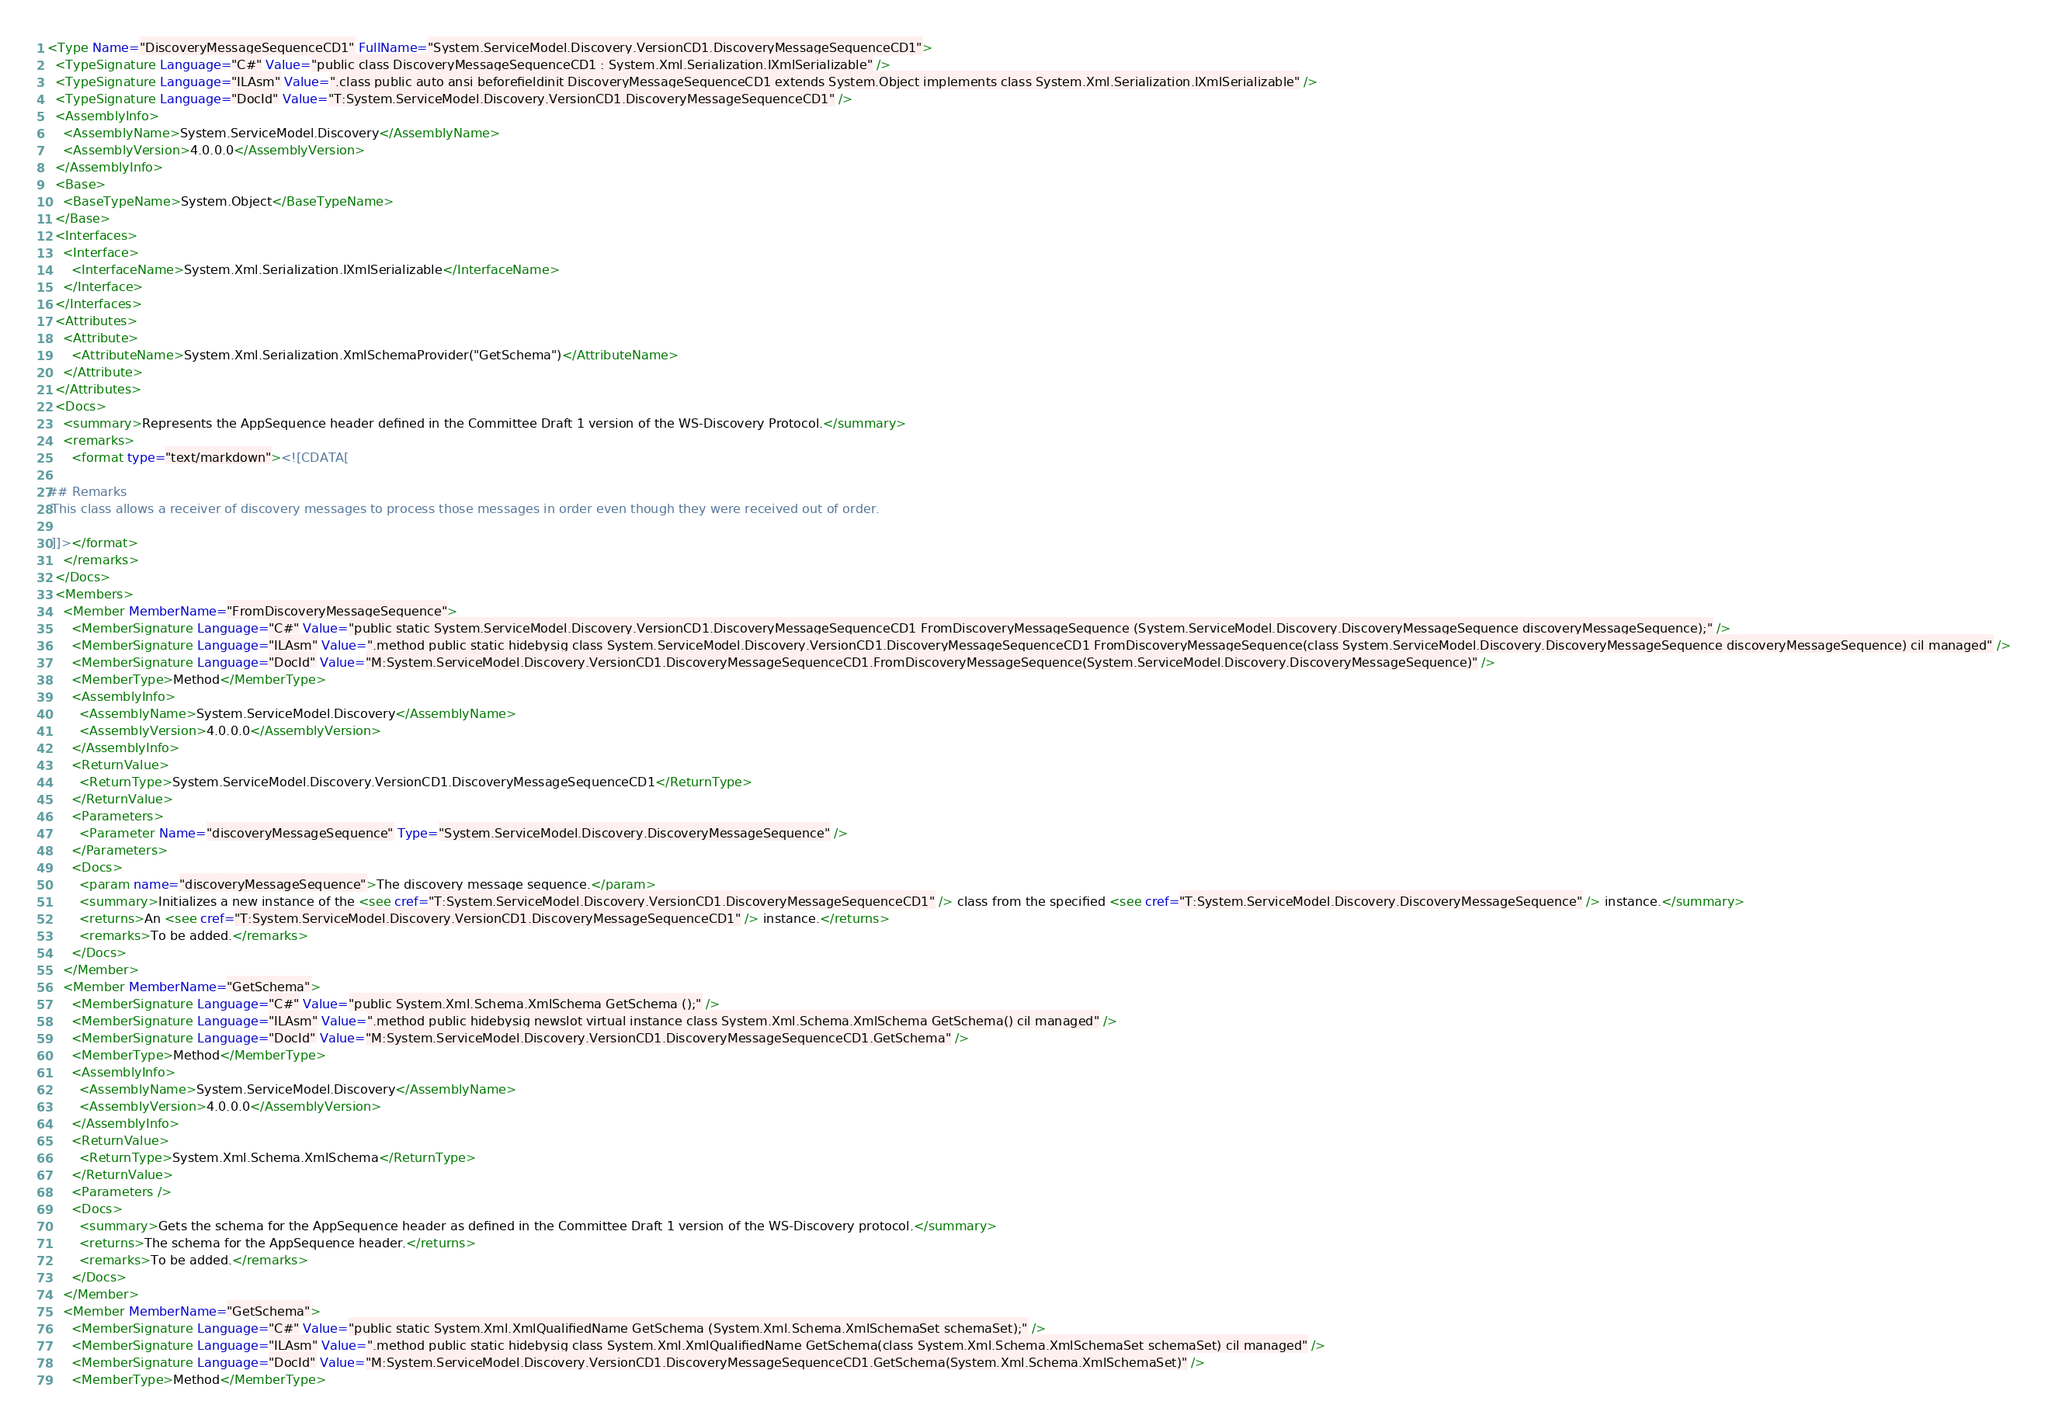Convert code to text. <code><loc_0><loc_0><loc_500><loc_500><_XML_><Type Name="DiscoveryMessageSequenceCD1" FullName="System.ServiceModel.Discovery.VersionCD1.DiscoveryMessageSequenceCD1">
  <TypeSignature Language="C#" Value="public class DiscoveryMessageSequenceCD1 : System.Xml.Serialization.IXmlSerializable" />
  <TypeSignature Language="ILAsm" Value=".class public auto ansi beforefieldinit DiscoveryMessageSequenceCD1 extends System.Object implements class System.Xml.Serialization.IXmlSerializable" />
  <TypeSignature Language="DocId" Value="T:System.ServiceModel.Discovery.VersionCD1.DiscoveryMessageSequenceCD1" />
  <AssemblyInfo>
    <AssemblyName>System.ServiceModel.Discovery</AssemblyName>
    <AssemblyVersion>4.0.0.0</AssemblyVersion>
  </AssemblyInfo>
  <Base>
    <BaseTypeName>System.Object</BaseTypeName>
  </Base>
  <Interfaces>
    <Interface>
      <InterfaceName>System.Xml.Serialization.IXmlSerializable</InterfaceName>
    </Interface>
  </Interfaces>
  <Attributes>
    <Attribute>
      <AttributeName>System.Xml.Serialization.XmlSchemaProvider("GetSchema")</AttributeName>
    </Attribute>
  </Attributes>
  <Docs>
    <summary>Represents the AppSequence header defined in the Committee Draft 1 version of the WS-Discovery Protocol.</summary>
    <remarks>
      <format type="text/markdown"><![CDATA[  
  
## Remarks  
 This class allows a receiver of discovery messages to process those messages in order even though they were received out of order.  
  
 ]]></format>
    </remarks>
  </Docs>
  <Members>
    <Member MemberName="FromDiscoveryMessageSequence">
      <MemberSignature Language="C#" Value="public static System.ServiceModel.Discovery.VersionCD1.DiscoveryMessageSequenceCD1 FromDiscoveryMessageSequence (System.ServiceModel.Discovery.DiscoveryMessageSequence discoveryMessageSequence);" />
      <MemberSignature Language="ILAsm" Value=".method public static hidebysig class System.ServiceModel.Discovery.VersionCD1.DiscoveryMessageSequenceCD1 FromDiscoveryMessageSequence(class System.ServiceModel.Discovery.DiscoveryMessageSequence discoveryMessageSequence) cil managed" />
      <MemberSignature Language="DocId" Value="M:System.ServiceModel.Discovery.VersionCD1.DiscoveryMessageSequenceCD1.FromDiscoveryMessageSequence(System.ServiceModel.Discovery.DiscoveryMessageSequence)" />
      <MemberType>Method</MemberType>
      <AssemblyInfo>
        <AssemblyName>System.ServiceModel.Discovery</AssemblyName>
        <AssemblyVersion>4.0.0.0</AssemblyVersion>
      </AssemblyInfo>
      <ReturnValue>
        <ReturnType>System.ServiceModel.Discovery.VersionCD1.DiscoveryMessageSequenceCD1</ReturnType>
      </ReturnValue>
      <Parameters>
        <Parameter Name="discoveryMessageSequence" Type="System.ServiceModel.Discovery.DiscoveryMessageSequence" />
      </Parameters>
      <Docs>
        <param name="discoveryMessageSequence">The discovery message sequence.</param>
        <summary>Initializes a new instance of the <see cref="T:System.ServiceModel.Discovery.VersionCD1.DiscoveryMessageSequenceCD1" /> class from the specified <see cref="T:System.ServiceModel.Discovery.DiscoveryMessageSequence" /> instance.</summary>
        <returns>An <see cref="T:System.ServiceModel.Discovery.VersionCD1.DiscoveryMessageSequenceCD1" /> instance.</returns>
        <remarks>To be added.</remarks>
      </Docs>
    </Member>
    <Member MemberName="GetSchema">
      <MemberSignature Language="C#" Value="public System.Xml.Schema.XmlSchema GetSchema ();" />
      <MemberSignature Language="ILAsm" Value=".method public hidebysig newslot virtual instance class System.Xml.Schema.XmlSchema GetSchema() cil managed" />
      <MemberSignature Language="DocId" Value="M:System.ServiceModel.Discovery.VersionCD1.DiscoveryMessageSequenceCD1.GetSchema" />
      <MemberType>Method</MemberType>
      <AssemblyInfo>
        <AssemblyName>System.ServiceModel.Discovery</AssemblyName>
        <AssemblyVersion>4.0.0.0</AssemblyVersion>
      </AssemblyInfo>
      <ReturnValue>
        <ReturnType>System.Xml.Schema.XmlSchema</ReturnType>
      </ReturnValue>
      <Parameters />
      <Docs>
        <summary>Gets the schema for the AppSequence header as defined in the Committee Draft 1 version of the WS-Discovery protocol.</summary>
        <returns>The schema for the AppSequence header.</returns>
        <remarks>To be added.</remarks>
      </Docs>
    </Member>
    <Member MemberName="GetSchema">
      <MemberSignature Language="C#" Value="public static System.Xml.XmlQualifiedName GetSchema (System.Xml.Schema.XmlSchemaSet schemaSet);" />
      <MemberSignature Language="ILAsm" Value=".method public static hidebysig class System.Xml.XmlQualifiedName GetSchema(class System.Xml.Schema.XmlSchemaSet schemaSet) cil managed" />
      <MemberSignature Language="DocId" Value="M:System.ServiceModel.Discovery.VersionCD1.DiscoveryMessageSequenceCD1.GetSchema(System.Xml.Schema.XmlSchemaSet)" />
      <MemberType>Method</MemberType></code> 